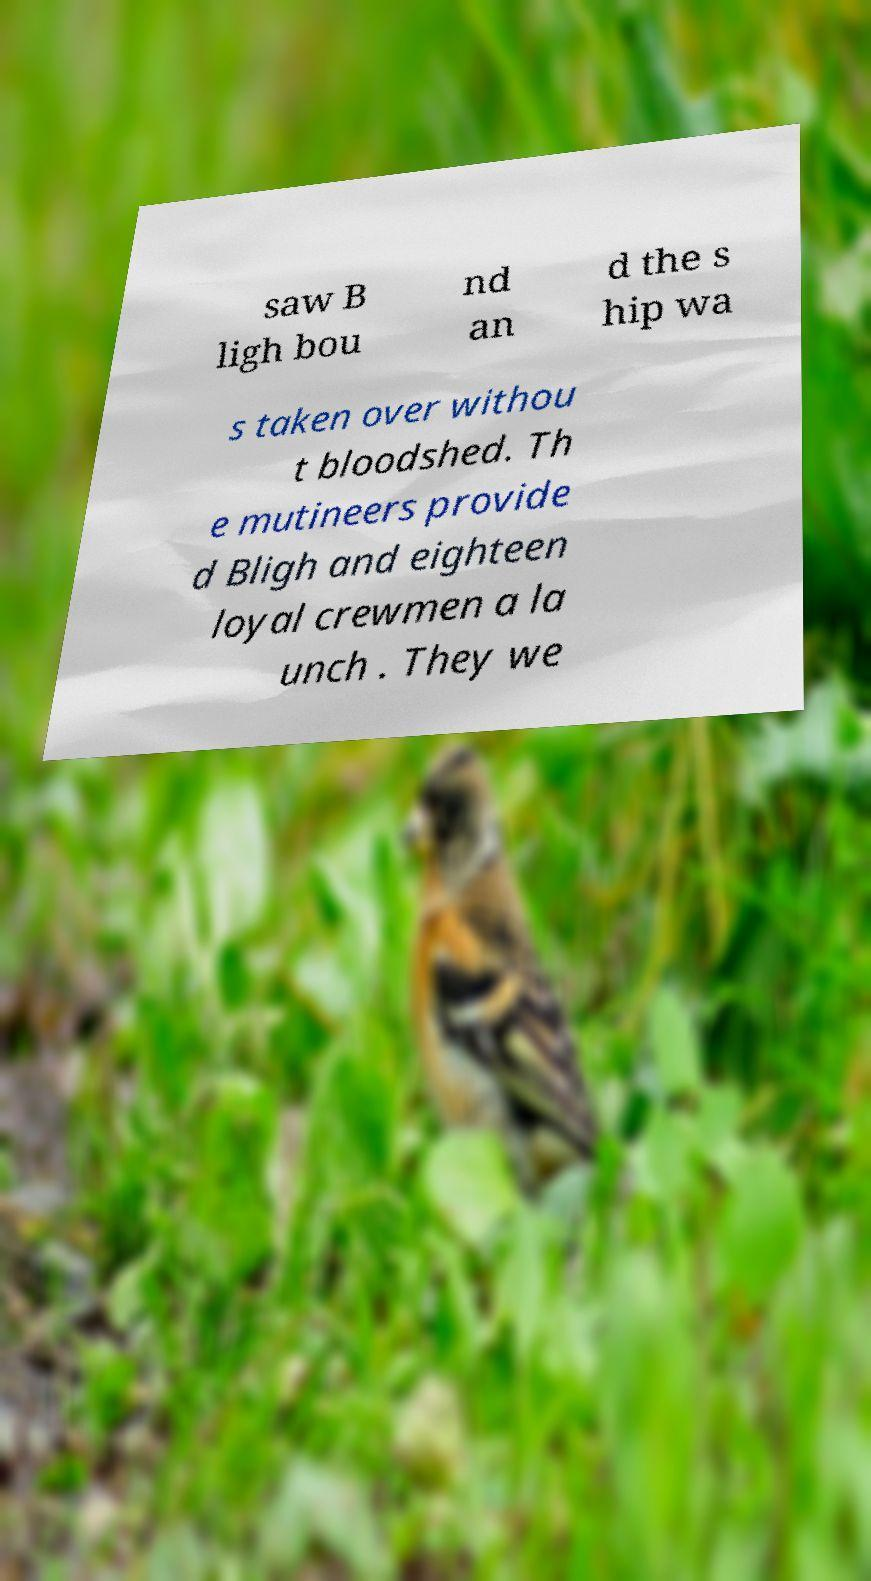Please read and relay the text visible in this image. What does it say? saw B ligh bou nd an d the s hip wa s taken over withou t bloodshed. Th e mutineers provide d Bligh and eighteen loyal crewmen a la unch . They we 